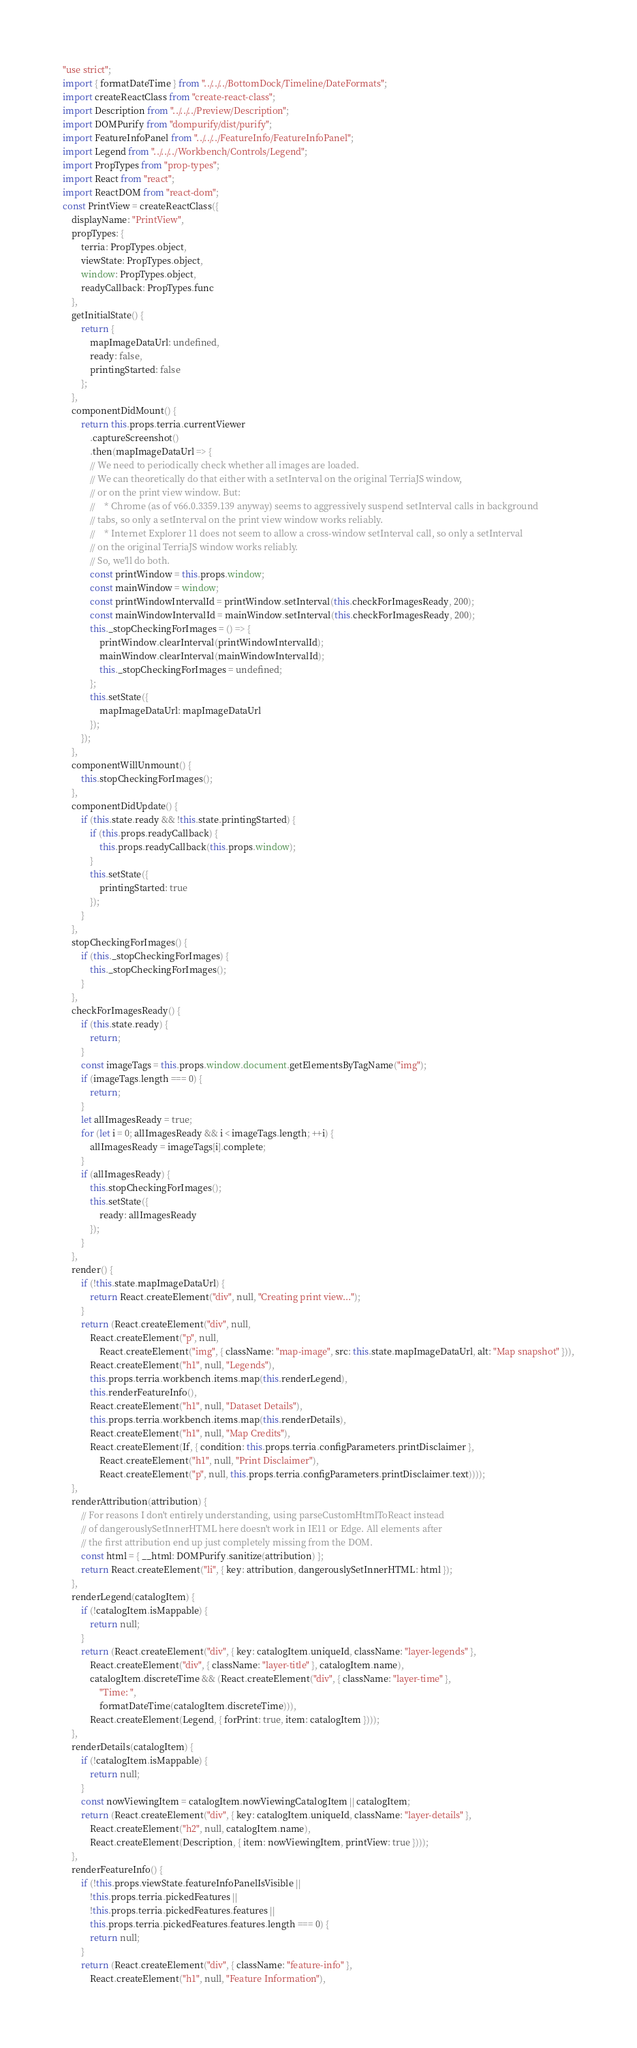<code> <loc_0><loc_0><loc_500><loc_500><_JavaScript_>"use strict";
import { formatDateTime } from "../../../BottomDock/Timeline/DateFormats";
import createReactClass from "create-react-class";
import Description from "../../../Preview/Description";
import DOMPurify from "dompurify/dist/purify";
import FeatureInfoPanel from "../../../FeatureInfo/FeatureInfoPanel";
import Legend from "../../../Workbench/Controls/Legend";
import PropTypes from "prop-types";
import React from "react";
import ReactDOM from "react-dom";
const PrintView = createReactClass({
    displayName: "PrintView",
    propTypes: {
        terria: PropTypes.object,
        viewState: PropTypes.object,
        window: PropTypes.object,
        readyCallback: PropTypes.func
    },
    getInitialState() {
        return {
            mapImageDataUrl: undefined,
            ready: false,
            printingStarted: false
        };
    },
    componentDidMount() {
        return this.props.terria.currentViewer
            .captureScreenshot()
            .then(mapImageDataUrl => {
            // We need to periodically check whether all images are loaded.
            // We can theoretically do that either with a setInterval on the original TerriaJS window,
            // or on the print view window. But:
            //    * Chrome (as of v66.0.3359.139 anyway) seems to aggressively suspend setInterval calls in background
            // tabs, so only a setInterval on the print view window works reliably.
            //    * Internet Explorer 11 does not seem to allow a cross-window setInterval call, so only a setInterval
            // on the original TerriaJS window works reliably.
            // So, we'll do both.
            const printWindow = this.props.window;
            const mainWindow = window;
            const printWindowIntervalId = printWindow.setInterval(this.checkForImagesReady, 200);
            const mainWindowIntervalId = mainWindow.setInterval(this.checkForImagesReady, 200);
            this._stopCheckingForImages = () => {
                printWindow.clearInterval(printWindowIntervalId);
                mainWindow.clearInterval(mainWindowIntervalId);
                this._stopCheckingForImages = undefined;
            };
            this.setState({
                mapImageDataUrl: mapImageDataUrl
            });
        });
    },
    componentWillUnmount() {
        this.stopCheckingForImages();
    },
    componentDidUpdate() {
        if (this.state.ready && !this.state.printingStarted) {
            if (this.props.readyCallback) {
                this.props.readyCallback(this.props.window);
            }
            this.setState({
                printingStarted: true
            });
        }
    },
    stopCheckingForImages() {
        if (this._stopCheckingForImages) {
            this._stopCheckingForImages();
        }
    },
    checkForImagesReady() {
        if (this.state.ready) {
            return;
        }
        const imageTags = this.props.window.document.getElementsByTagName("img");
        if (imageTags.length === 0) {
            return;
        }
        let allImagesReady = true;
        for (let i = 0; allImagesReady && i < imageTags.length; ++i) {
            allImagesReady = imageTags[i].complete;
        }
        if (allImagesReady) {
            this.stopCheckingForImages();
            this.setState({
                ready: allImagesReady
            });
        }
    },
    render() {
        if (!this.state.mapImageDataUrl) {
            return React.createElement("div", null, "Creating print view...");
        }
        return (React.createElement("div", null,
            React.createElement("p", null,
                React.createElement("img", { className: "map-image", src: this.state.mapImageDataUrl, alt: "Map snapshot" })),
            React.createElement("h1", null, "Legends"),
            this.props.terria.workbench.items.map(this.renderLegend),
            this.renderFeatureInfo(),
            React.createElement("h1", null, "Dataset Details"),
            this.props.terria.workbench.items.map(this.renderDetails),
            React.createElement("h1", null, "Map Credits"),
            React.createElement(If, { condition: this.props.terria.configParameters.printDisclaimer },
                React.createElement("h1", null, "Print Disclaimer"),
                React.createElement("p", null, this.props.terria.configParameters.printDisclaimer.text))));
    },
    renderAttribution(attribution) {
        // For reasons I don't entirely understanding, using parseCustomHtmlToReact instead
        // of dangerouslySetInnerHTML here doesn't work in IE11 or Edge. All elements after
        // the first attribution end up just completely missing from the DOM.
        const html = { __html: DOMPurify.sanitize(attribution) };
        return React.createElement("li", { key: attribution, dangerouslySetInnerHTML: html });
    },
    renderLegend(catalogItem) {
        if (!catalogItem.isMappable) {
            return null;
        }
        return (React.createElement("div", { key: catalogItem.uniqueId, className: "layer-legends" },
            React.createElement("div", { className: "layer-title" }, catalogItem.name),
            catalogItem.discreteTime && (React.createElement("div", { className: "layer-time" },
                "Time: ",
                formatDateTime(catalogItem.discreteTime))),
            React.createElement(Legend, { forPrint: true, item: catalogItem })));
    },
    renderDetails(catalogItem) {
        if (!catalogItem.isMappable) {
            return null;
        }
        const nowViewingItem = catalogItem.nowViewingCatalogItem || catalogItem;
        return (React.createElement("div", { key: catalogItem.uniqueId, className: "layer-details" },
            React.createElement("h2", null, catalogItem.name),
            React.createElement(Description, { item: nowViewingItem, printView: true })));
    },
    renderFeatureInfo() {
        if (!this.props.viewState.featureInfoPanelIsVisible ||
            !this.props.terria.pickedFeatures ||
            !this.props.terria.pickedFeatures.features ||
            this.props.terria.pickedFeatures.features.length === 0) {
            return null;
        }
        return (React.createElement("div", { className: "feature-info" },
            React.createElement("h1", null, "Feature Information"),</code> 